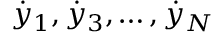<formula> <loc_0><loc_0><loc_500><loc_500>{ \dot { y } } _ { 1 } , { \dot { y } } _ { 3 } , \dots , { \dot { y } } _ { N }</formula> 